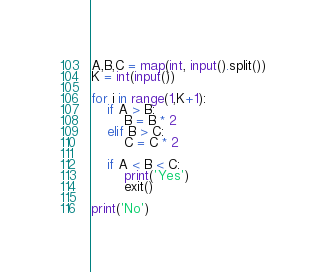Convert code to text. <code><loc_0><loc_0><loc_500><loc_500><_Python_>A,B,C = map(int, input().split())
K = int(input())

for i in range(1,K+1):
    if A > B:
        B = B * 2
    elif B > C:
        C = C * 2

    if A < B < C:
        print('Yes')
        exit()

print('No')
</code> 